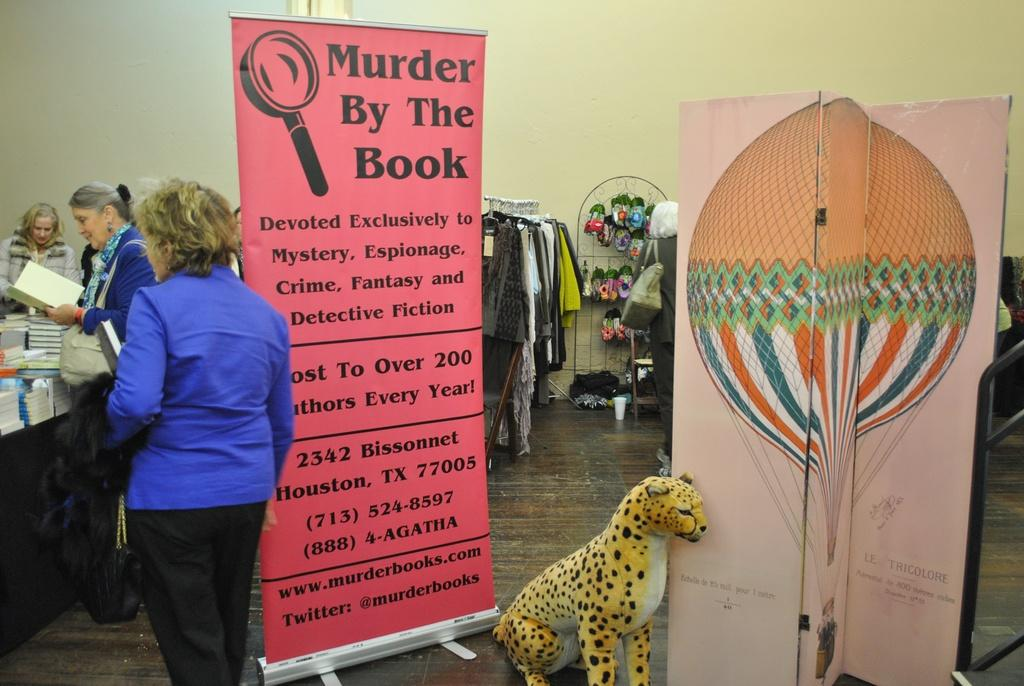Who is present in the image? There are women in the image. What can be seen hanging in the image? There are banners in the image. What is on the floor in the image? There is a toy animal on the floor. What items are on a table in the image? There are books on a table. What can be seen in the background of the image? Clothes are visible in the background, as well as objects on a stand and a wall. What is present in the background that is used for holding liquids? There is a glass in the background. What type of train can be seen in the image? There are no trains present in the image. What is the bun used for in the image? There is no bun present in the image. 